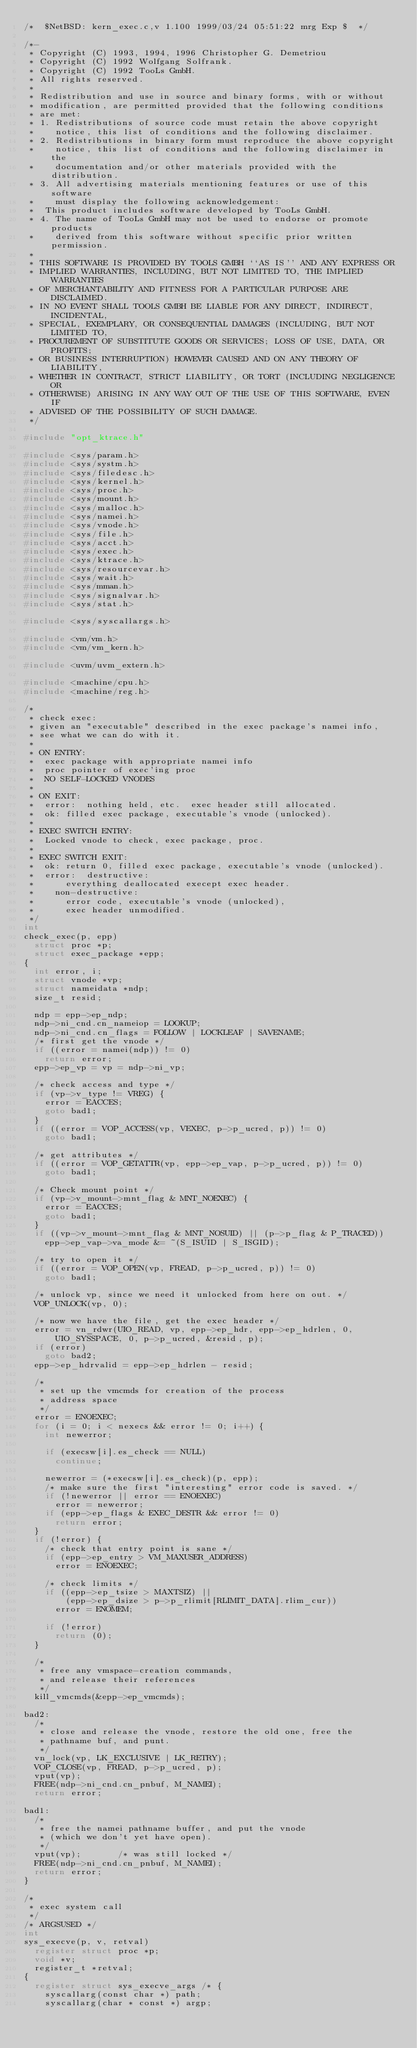Convert code to text. <code><loc_0><loc_0><loc_500><loc_500><_C_>/*	$NetBSD: kern_exec.c,v 1.100 1999/03/24 05:51:22 mrg Exp $	*/

/*-
 * Copyright (C) 1993, 1994, 1996 Christopher G. Demetriou
 * Copyright (C) 1992 Wolfgang Solfrank.
 * Copyright (C) 1992 TooLs GmbH.
 * All rights reserved.
 *
 * Redistribution and use in source and binary forms, with or without
 * modification, are permitted provided that the following conditions
 * are met:
 * 1. Redistributions of source code must retain the above copyright
 *    notice, this list of conditions and the following disclaimer.
 * 2. Redistributions in binary form must reproduce the above copyright
 *    notice, this list of conditions and the following disclaimer in the
 *    documentation and/or other materials provided with the distribution.
 * 3. All advertising materials mentioning features or use of this software
 *    must display the following acknowledgement:
 *	This product includes software developed by TooLs GmbH.
 * 4. The name of TooLs GmbH may not be used to endorse or promote products
 *    derived from this software without specific prior written permission.
 *
 * THIS SOFTWARE IS PROVIDED BY TOOLS GMBH ``AS IS'' AND ANY EXPRESS OR
 * IMPLIED WARRANTIES, INCLUDING, BUT NOT LIMITED TO, THE IMPLIED WARRANTIES
 * OF MERCHANTABILITY AND FITNESS FOR A PARTICULAR PURPOSE ARE DISCLAIMED.
 * IN NO EVENT SHALL TOOLS GMBH BE LIABLE FOR ANY DIRECT, INDIRECT, INCIDENTAL,
 * SPECIAL, EXEMPLARY, OR CONSEQUENTIAL DAMAGES (INCLUDING, BUT NOT LIMITED TO,
 * PROCUREMENT OF SUBSTITUTE GOODS OR SERVICES; LOSS OF USE, DATA, OR PROFITS;
 * OR BUSINESS INTERRUPTION) HOWEVER CAUSED AND ON ANY THEORY OF LIABILITY,
 * WHETHER IN CONTRACT, STRICT LIABILITY, OR TORT (INCLUDING NEGLIGENCE OR
 * OTHERWISE) ARISING IN ANY WAY OUT OF THE USE OF THIS SOFTWARE, EVEN IF
 * ADVISED OF THE POSSIBILITY OF SUCH DAMAGE.
 */

#include "opt_ktrace.h"

#include <sys/param.h>
#include <sys/systm.h>
#include <sys/filedesc.h>
#include <sys/kernel.h>
#include <sys/proc.h>
#include <sys/mount.h>
#include <sys/malloc.h>
#include <sys/namei.h>
#include <sys/vnode.h>
#include <sys/file.h>
#include <sys/acct.h>
#include <sys/exec.h>
#include <sys/ktrace.h>
#include <sys/resourcevar.h>
#include <sys/wait.h>
#include <sys/mman.h>
#include <sys/signalvar.h>
#include <sys/stat.h>

#include <sys/syscallargs.h>

#include <vm/vm.h>
#include <vm/vm_kern.h>

#include <uvm/uvm_extern.h>

#include <machine/cpu.h>
#include <machine/reg.h>

/*
 * check exec:
 * given an "executable" described in the exec package's namei info,
 * see what we can do with it.
 *
 * ON ENTRY:
 *	exec package with appropriate namei info
 *	proc pointer of exec'ing proc
 *	NO SELF-LOCKED VNODES
 *
 * ON EXIT:
 *	error:	nothing held, etc.  exec header still allocated.
 *	ok:	filled exec package, executable's vnode (unlocked).
 *
 * EXEC SWITCH ENTRY:
 * 	Locked vnode to check, exec package, proc.
 *
 * EXEC SWITCH EXIT:
 *	ok:	return 0, filled exec package, executable's vnode (unlocked).
 *	error:	destructive:
 *			everything deallocated execept exec header.
 *		non-destructive:
 *			error code, executable's vnode (unlocked),
 *			exec header unmodified.
 */
int
check_exec(p, epp)
	struct proc *p;
	struct exec_package *epp;
{
	int error, i;
	struct vnode *vp;
	struct nameidata *ndp;
	size_t resid;

	ndp = epp->ep_ndp;
	ndp->ni_cnd.cn_nameiop = LOOKUP;
	ndp->ni_cnd.cn_flags = FOLLOW | LOCKLEAF | SAVENAME;
	/* first get the vnode */
	if ((error = namei(ndp)) != 0)
		return error;
	epp->ep_vp = vp = ndp->ni_vp;

	/* check access and type */
	if (vp->v_type != VREG) {
		error = EACCES;
		goto bad1;
	}
	if ((error = VOP_ACCESS(vp, VEXEC, p->p_ucred, p)) != 0)
		goto bad1;

	/* get attributes */
	if ((error = VOP_GETATTR(vp, epp->ep_vap, p->p_ucred, p)) != 0)
		goto bad1;

	/* Check mount point */
	if (vp->v_mount->mnt_flag & MNT_NOEXEC) {
		error = EACCES;
		goto bad1;
	}
	if ((vp->v_mount->mnt_flag & MNT_NOSUID) || (p->p_flag & P_TRACED))
		epp->ep_vap->va_mode &= ~(S_ISUID | S_ISGID);

	/* try to open it */
	if ((error = VOP_OPEN(vp, FREAD, p->p_ucred, p)) != 0)
		goto bad1;

	/* unlock vp, since we need it unlocked from here on out. */
	VOP_UNLOCK(vp, 0);

	/* now we have the file, get the exec header */
	error = vn_rdwr(UIO_READ, vp, epp->ep_hdr, epp->ep_hdrlen, 0,
			UIO_SYSSPACE, 0, p->p_ucred, &resid, p);
	if (error)
		goto bad2;
	epp->ep_hdrvalid = epp->ep_hdrlen - resid;

	/*
	 * set up the vmcmds for creation of the process
	 * address space
	 */
	error = ENOEXEC;
	for (i = 0; i < nexecs && error != 0; i++) {
		int newerror;

		if (execsw[i].es_check == NULL)
			continue;

		newerror = (*execsw[i].es_check)(p, epp);
		/* make sure the first "interesting" error code is saved. */
		if (!newerror || error == ENOEXEC)
			error = newerror;
		if (epp->ep_flags & EXEC_DESTR && error != 0)
			return error;
	}
	if (!error) {
		/* check that entry point is sane */
		if (epp->ep_entry > VM_MAXUSER_ADDRESS)
			error = ENOEXEC;

		/* check limits */
		if ((epp->ep_tsize > MAXTSIZ) ||
		    (epp->ep_dsize > p->p_rlimit[RLIMIT_DATA].rlim_cur))
			error = ENOMEM;

		if (!error)
			return (0);
	}

	/*
	 * free any vmspace-creation commands,
	 * and release their references
	 */
	kill_vmcmds(&epp->ep_vmcmds);

bad2:
	/*
	 * close and release the vnode, restore the old one, free the
	 * pathname buf, and punt.
	 */
	vn_lock(vp, LK_EXCLUSIVE | LK_RETRY);
	VOP_CLOSE(vp, FREAD, p->p_ucred, p);
	vput(vp);
	FREE(ndp->ni_cnd.cn_pnbuf, M_NAMEI);
	return error;

bad1:
	/*
	 * free the namei pathname buffer, and put the vnode
	 * (which we don't yet have open).
	 */
	vput(vp);				/* was still locked */
	FREE(ndp->ni_cnd.cn_pnbuf, M_NAMEI);
	return error;
}

/*
 * exec system call
 */
/* ARGSUSED */
int
sys_execve(p, v, retval)
	register struct proc *p;
	void *v;
	register_t *retval;
{
	register struct sys_execve_args /* {
		syscallarg(const char *) path;
		syscallarg(char * const *) argp;</code> 